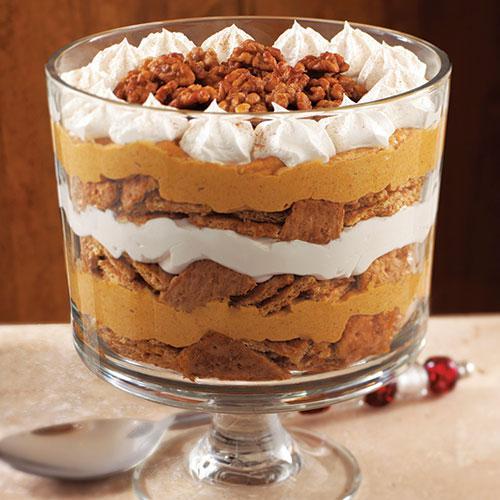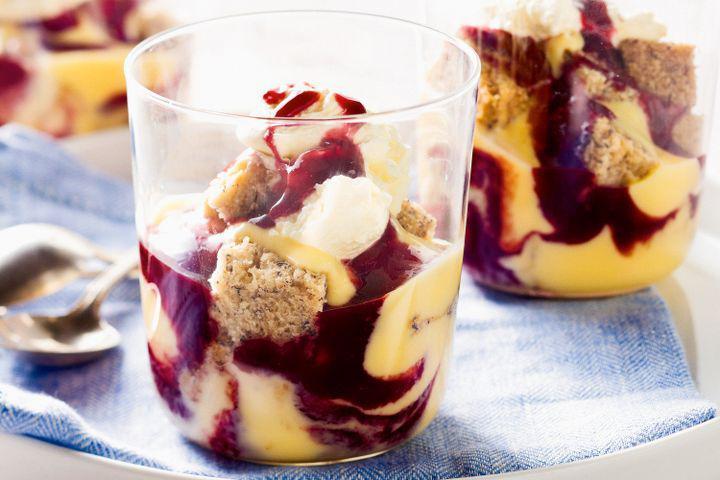The first image is the image on the left, the second image is the image on the right. Assess this claim about the two images: "The left image shows one layered dessert served in a footed glass.". Correct or not? Answer yes or no. Yes. 